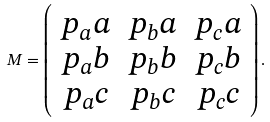<formula> <loc_0><loc_0><loc_500><loc_500>M = \left ( \begin{array} { c c c } p _ { a } a & p _ { b } a & p _ { c } a \\ p _ { a } b & p _ { b } b & p _ { c } b \\ p _ { a } c & p _ { b } c & p _ { c } c \\ \end{array} \right ) .</formula> 